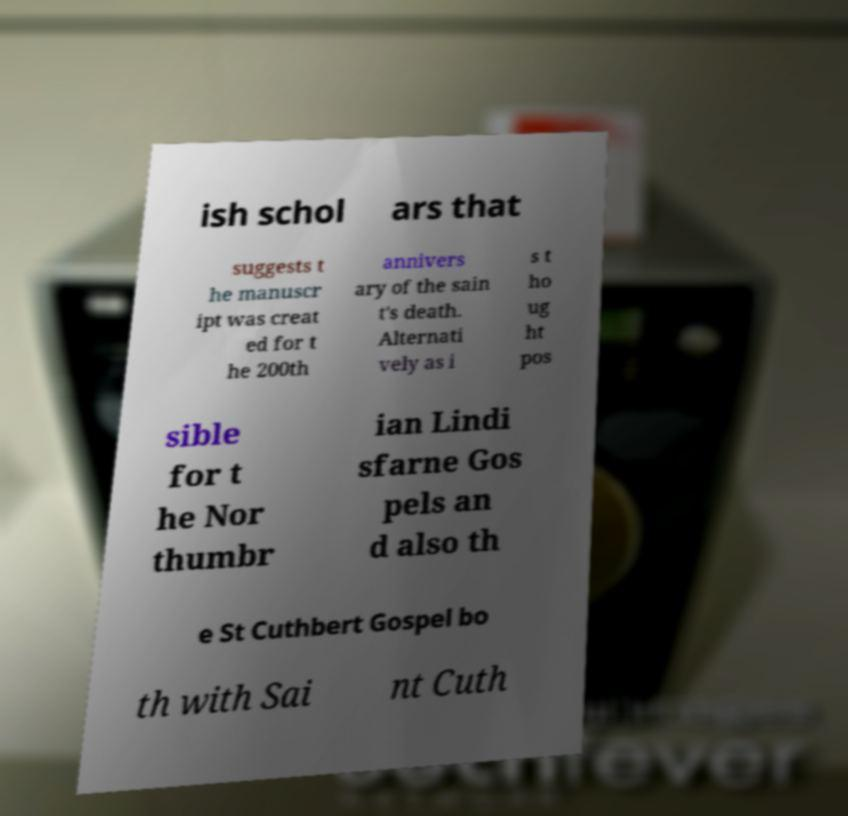For documentation purposes, I need the text within this image transcribed. Could you provide that? ish schol ars that suggests t he manuscr ipt was creat ed for t he 200th annivers ary of the sain t's death. Alternati vely as i s t ho ug ht pos sible for t he Nor thumbr ian Lindi sfarne Gos pels an d also th e St Cuthbert Gospel bo th with Sai nt Cuth 